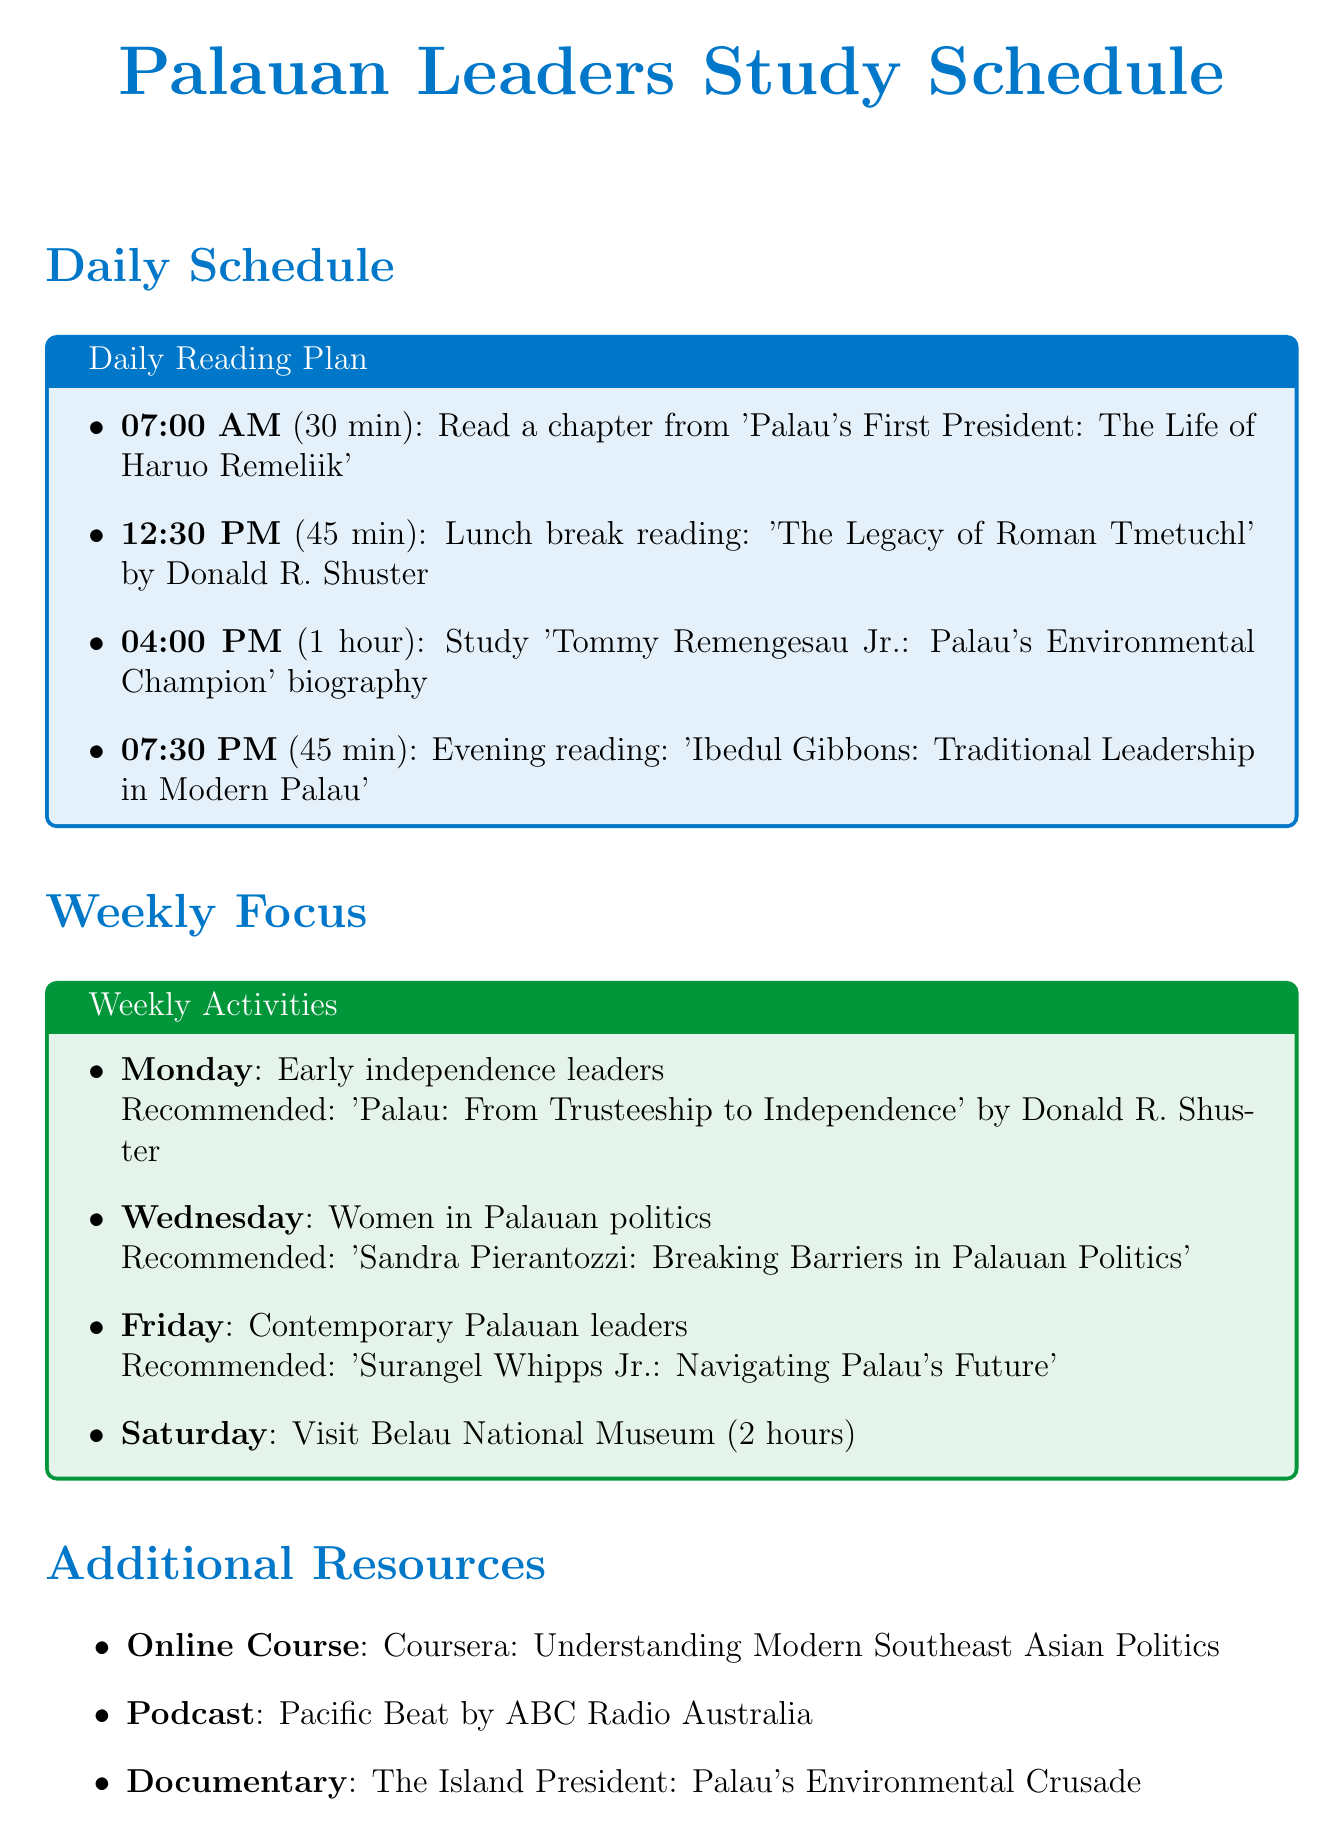What time is the morning reading scheduled for? The morning reading is scheduled for 07:00 AM.
Answer: 07:00 AM How long is the lunch break reading? The lunch break reading activity lasts for 45 minutes.
Answer: 45 minutes What is the focus for Wednesday's reading? Wednesday's focus is on women in Palauan politics.
Answer: Women in Palauan politics Which leader's biography is studied at 04:00 PM? The biography studied at 04:00 PM is 'Tommy Remengesau Jr.: Palau's Environmental Champion'.
Answer: Tommy Remengesau Jr What is the recommended book for Monday? The recommended book for Monday is 'Palau: From Trusteeship to Independence' by Donald R. Shuster.
Answer: Palau: From Trusteeship to Independence What type of additional resource is "The Island President: Palau's Environmental Crusade"? It is a documentary.
Answer: Documentary How many study goals are listed in the document? There are four study goals listed in the document.
Answer: Four Where is the Annual Constitutional Convention Commemoration held? It is held at the Palau National Capitol.
Answer: Palau National Capitol What is studied during the Saturday activity? On Saturday, the activity is a visit to the Belau National Museum.
Answer: Visit to the Belau National Museum 